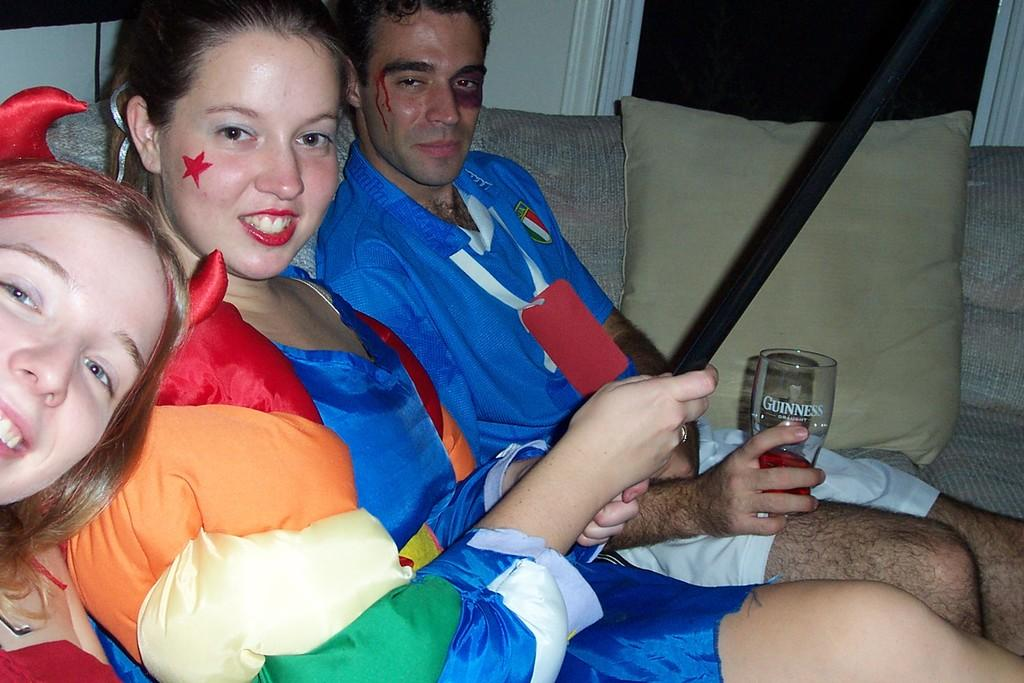<image>
Provide a brief description of the given image. The man in this picture is drinking a beverage from a Guinness pint glass. 